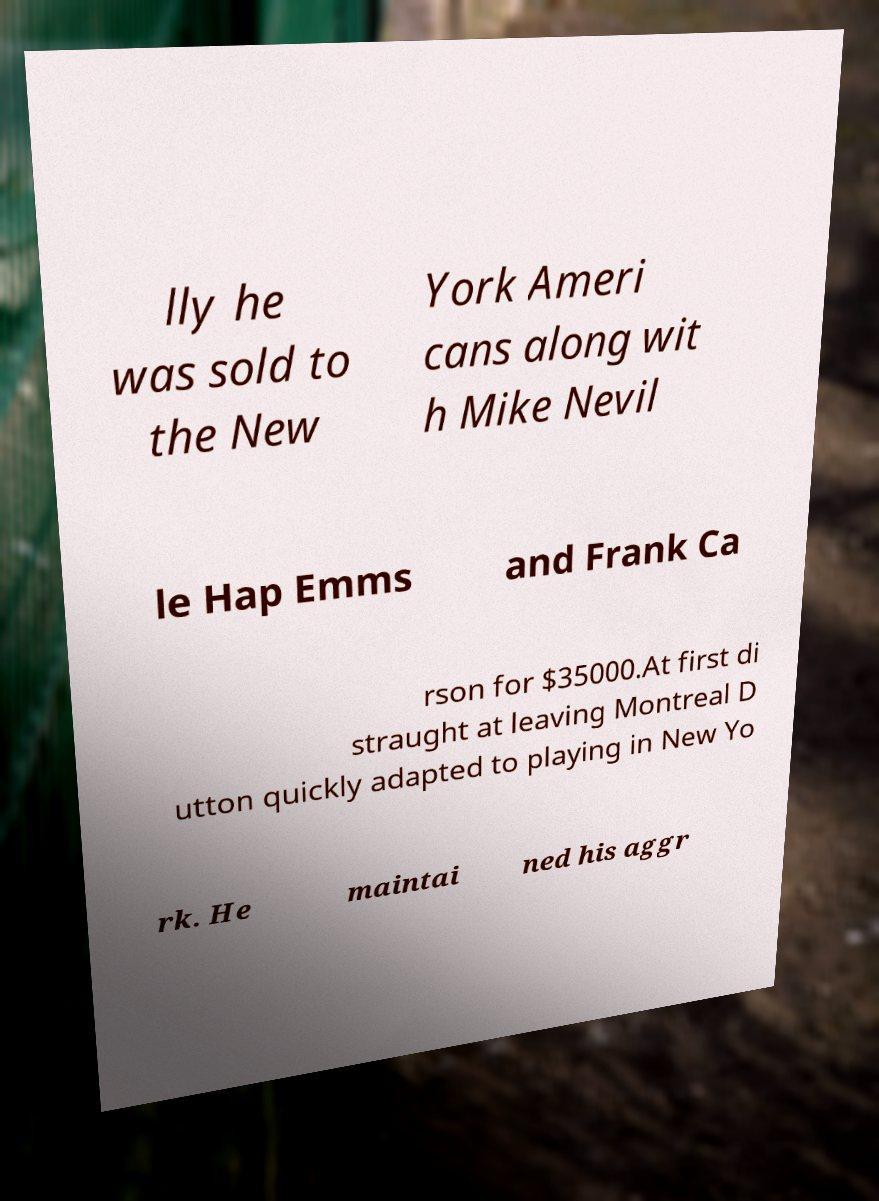Please read and relay the text visible in this image. What does it say? lly he was sold to the New York Ameri cans along wit h Mike Nevil le Hap Emms and Frank Ca rson for $35000.At first di straught at leaving Montreal D utton quickly adapted to playing in New Yo rk. He maintai ned his aggr 